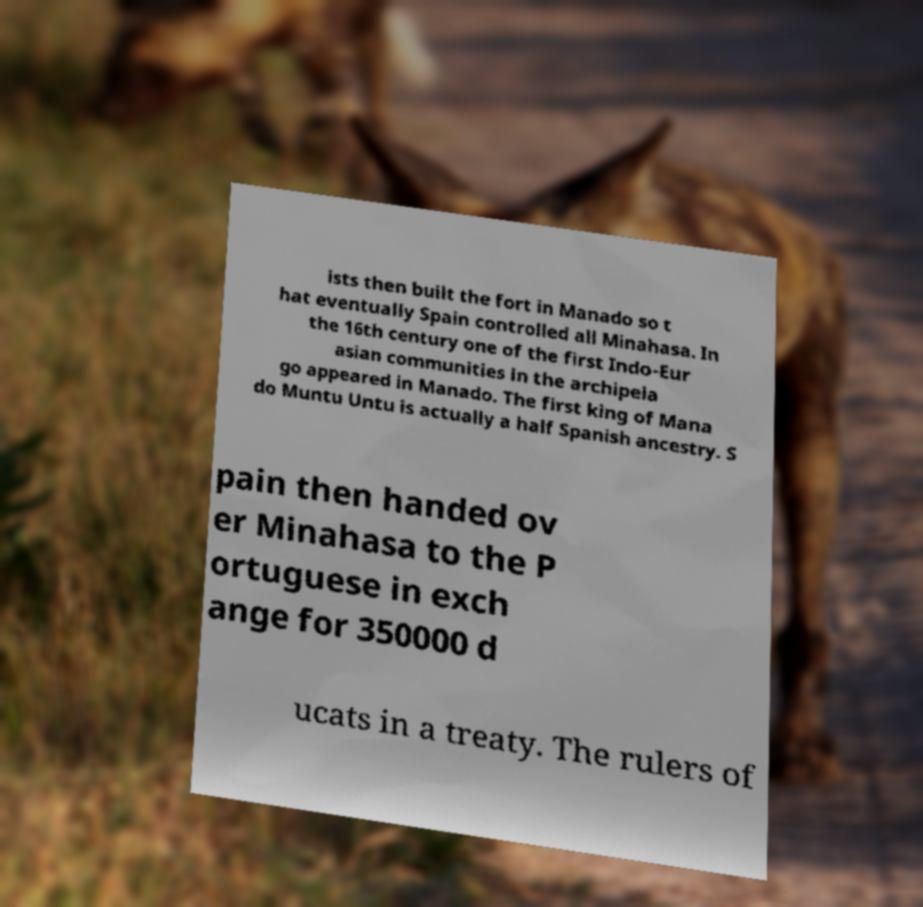Please read and relay the text visible in this image. What does it say? ists then built the fort in Manado so t hat eventually Spain controlled all Minahasa. In the 16th century one of the first Indo-Eur asian communities in the archipela go appeared in Manado. The first king of Mana do Muntu Untu is actually a half Spanish ancestry. S pain then handed ov er Minahasa to the P ortuguese in exch ange for 350000 d ucats in a treaty. The rulers of 